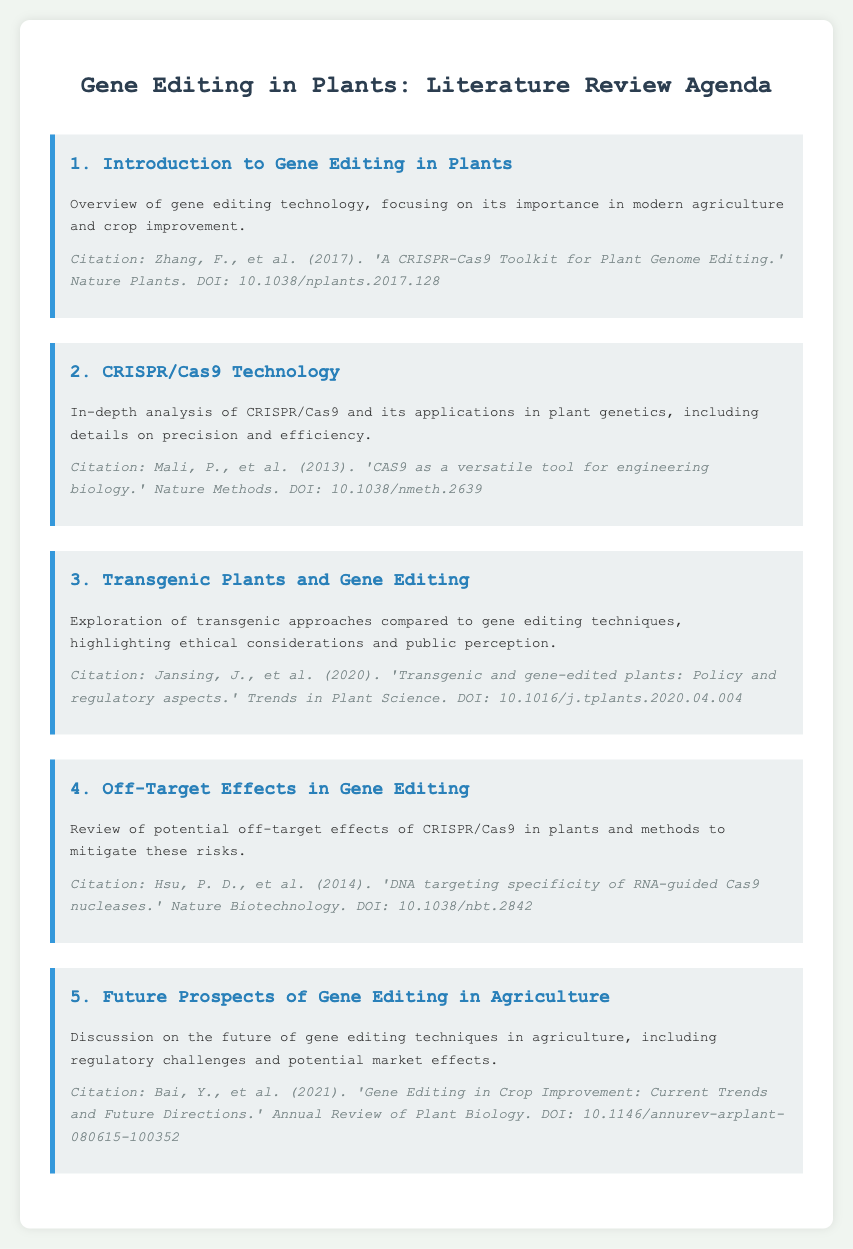What is the title of the agenda? The title is clearly stated at the top of the document, summarizing the document's purpose.
Answer: Gene Editing in Plants: Literature Review Agenda Who are the authors of the first citation? The authors' names are listed in full in the citation under the first agenda item.
Answer: Zhang, F., et al What year was the CRISPR/Cas9 paper published? The publication year is included in the citation for the second agenda item.
Answer: 2013 What is the focus of the third agenda item? The content of the third item explains its main focus concerning gene editing techniques and public perception.
Answer: Transgenic approaches compared to gene editing techniques What potential risk is addressed in the fourth agenda item? The fourth item specifically mentions a particular risk associated with gene editing technologies.
Answer: Off-target effects How many agenda items are listed in the document? The document enumerates the main discussion points, which can be counted.
Answer: 5 What is the DOI for the fifth citation? The DOI is explicitly provided in the citation for the fifth agenda item.
Answer: 10.1146/annurev-arplant-080615-100352 What technique is the focus of the second agenda item? The second item directly states the technique being analyzed in detail.
Answer: CRISPR/Cas9 What is the primary topic of the fourth agenda item? The fourth item clearly indicates its main discussion topic regarding gene editing.
Answer: Off-Target Effects in Gene Editing 